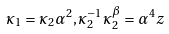Convert formula to latex. <formula><loc_0><loc_0><loc_500><loc_500>\kappa _ { 1 } = \kappa _ { 2 } \alpha ^ { 2 } , \kappa _ { 2 } ^ { - 1 } \kappa _ { 2 } ^ { \beta } = \alpha ^ { 4 } z</formula> 